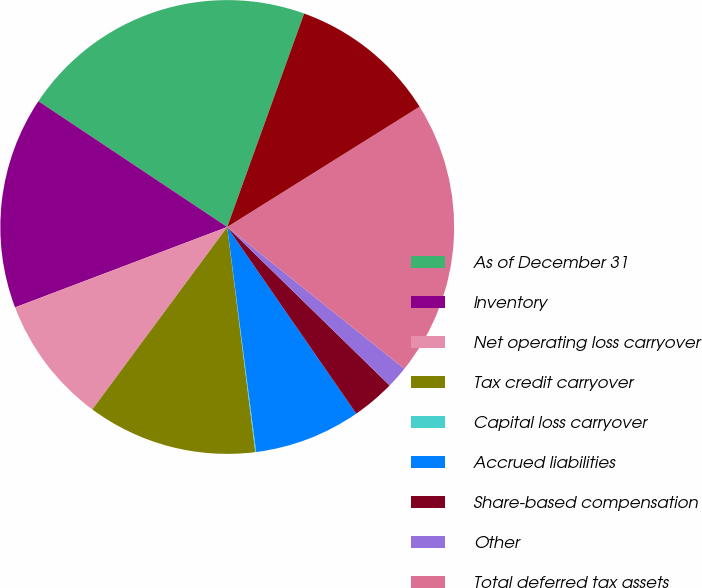Convert chart. <chart><loc_0><loc_0><loc_500><loc_500><pie_chart><fcel>As of December 31<fcel>Inventory<fcel>Net operating loss carryover<fcel>Tax credit carryover<fcel>Capital loss carryover<fcel>Accrued liabilities<fcel>Share-based compensation<fcel>Other<fcel>Total deferred tax assets<fcel>Less Valuation allowances<nl><fcel>21.15%<fcel>15.12%<fcel>9.1%<fcel>12.11%<fcel>0.06%<fcel>7.59%<fcel>3.07%<fcel>1.56%<fcel>19.64%<fcel>10.6%<nl></chart> 